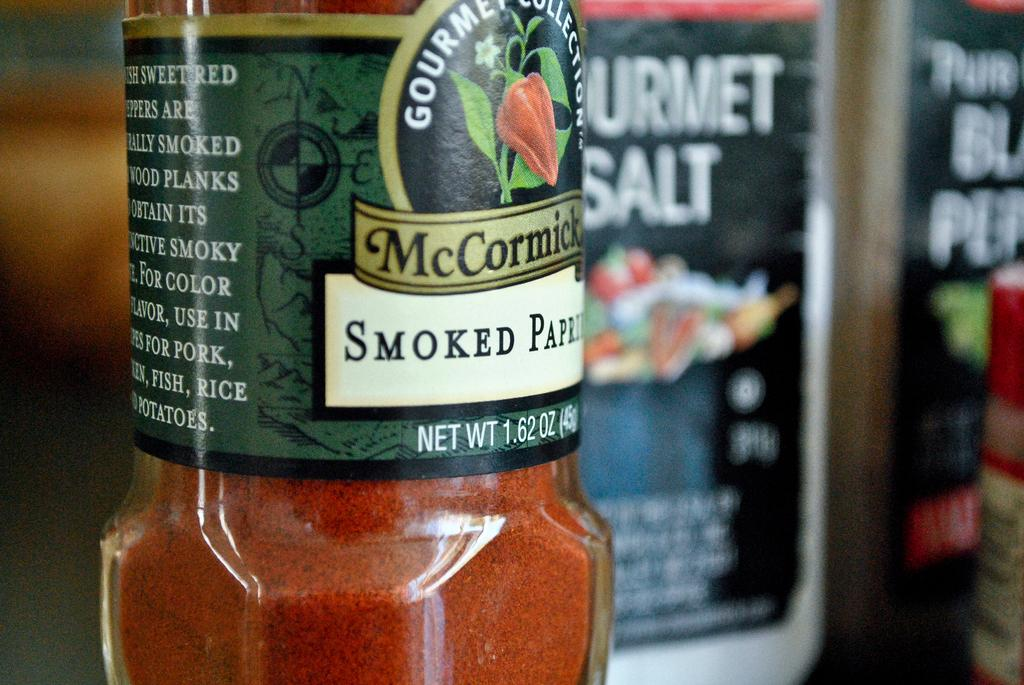<image>
Write a terse but informative summary of the picture. A jar of smoke paparika with a green label 